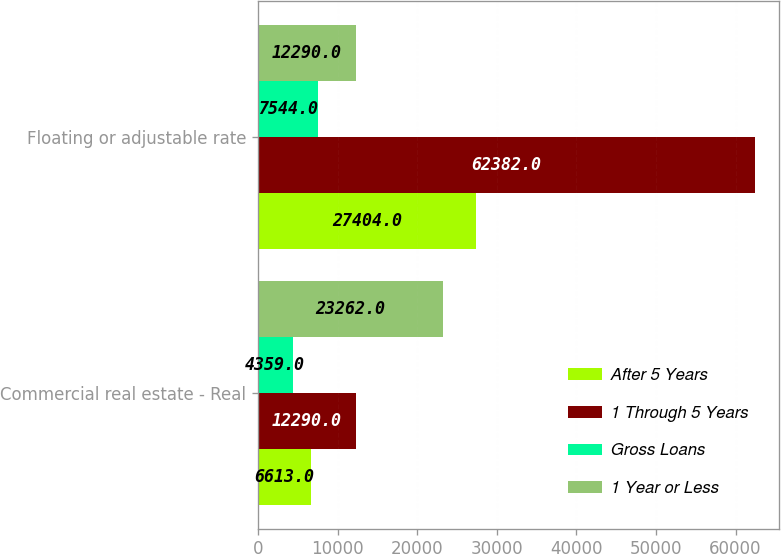Convert chart to OTSL. <chart><loc_0><loc_0><loc_500><loc_500><stacked_bar_chart><ecel><fcel>Commercial real estate - Real<fcel>Floating or adjustable rate<nl><fcel>After 5 Years<fcel>6613<fcel>27404<nl><fcel>1 Through 5 Years<fcel>12290<fcel>62382<nl><fcel>Gross Loans<fcel>4359<fcel>7544<nl><fcel>1 Year or Less<fcel>23262<fcel>12290<nl></chart> 